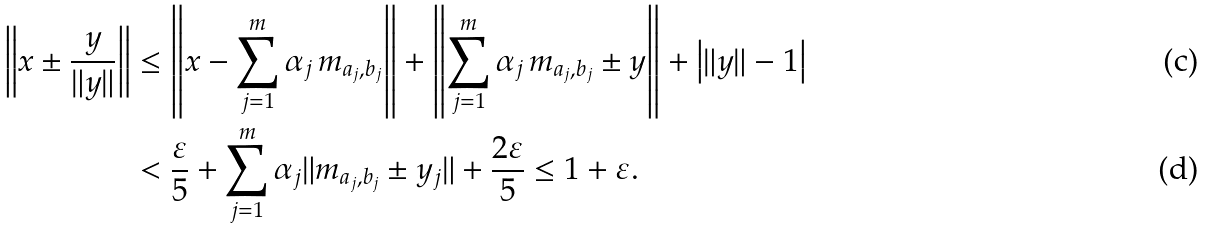Convert formula to latex. <formula><loc_0><loc_0><loc_500><loc_500>\left \| x \pm \frac { y } { \| y \| } \right \| & \leq \left \| x - \sum _ { j = 1 } ^ { m } \alpha _ { j } \, m _ { a _ { j } , b _ { j } } \right \| + \left \| \sum _ { j = 1 } ^ { m } \alpha _ { j } \, m _ { a _ { j } , b _ { j } } \pm y \right \| + \left | \| y \| - 1 \right | \\ & < \frac { \varepsilon } { 5 } + \sum _ { j = 1 } ^ { m } \alpha _ { j } \| m _ { a _ { j } , b _ { j } } \pm y _ { j } \| + \frac { 2 \varepsilon } { 5 } \leq 1 + \varepsilon .</formula> 